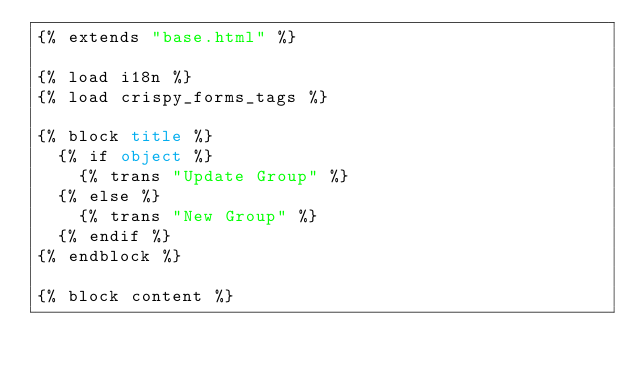<code> <loc_0><loc_0><loc_500><loc_500><_HTML_>{% extends "base.html" %}

{% load i18n %}
{% load crispy_forms_tags %}

{% block title %}
  {% if object %}
    {% trans "Update Group" %}
  {% else %}
    {% trans "New Group" %}
  {% endif %}
{% endblock %}

{% block content %}</code> 